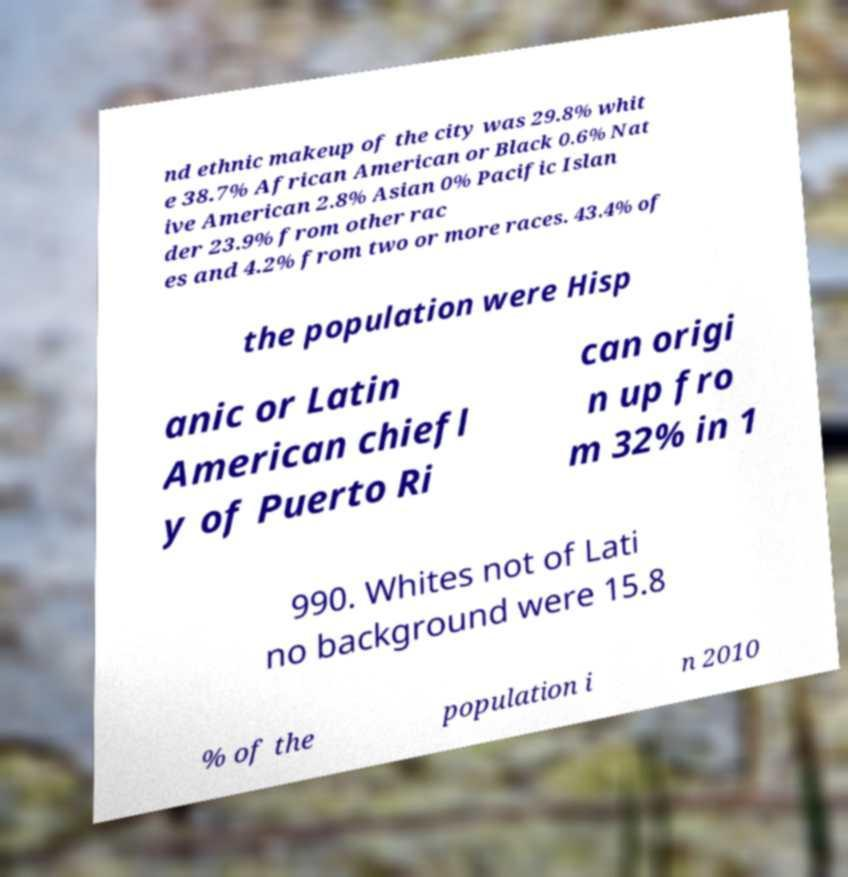There's text embedded in this image that I need extracted. Can you transcribe it verbatim? nd ethnic makeup of the city was 29.8% whit e 38.7% African American or Black 0.6% Nat ive American 2.8% Asian 0% Pacific Islan der 23.9% from other rac es and 4.2% from two or more races. 43.4% of the population were Hisp anic or Latin American chiefl y of Puerto Ri can origi n up fro m 32% in 1 990. Whites not of Lati no background were 15.8 % of the population i n 2010 